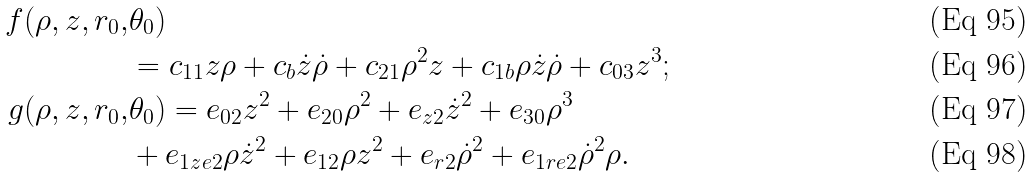<formula> <loc_0><loc_0><loc_500><loc_500>f ( \rho , z , r _ { 0 } , & \theta _ { 0 } ) \\ & = c _ { 1 1 } z \rho + c _ { b } \dot { z } \dot { \rho } + c _ { 2 1 } \rho ^ { 2 } z + c _ { 1 b } \rho \dot { z } \dot { \rho } + c _ { 0 3 } z ^ { 3 } ; \\ g ( \rho , z , r _ { 0 } , & \theta _ { 0 } ) = e _ { 0 2 } z ^ { 2 } + e _ { 2 0 } \rho ^ { 2 } + e _ { z 2 } \dot { z } ^ { 2 } + e _ { 3 0 } \rho ^ { 3 } \\ & + e _ { 1 z e 2 } \rho \dot { z } ^ { 2 } + e _ { 1 2 } \rho z ^ { 2 } + e _ { r 2 } \dot { \rho } ^ { 2 } + e _ { 1 r e 2 } \dot { \rho } ^ { 2 } \rho .</formula> 